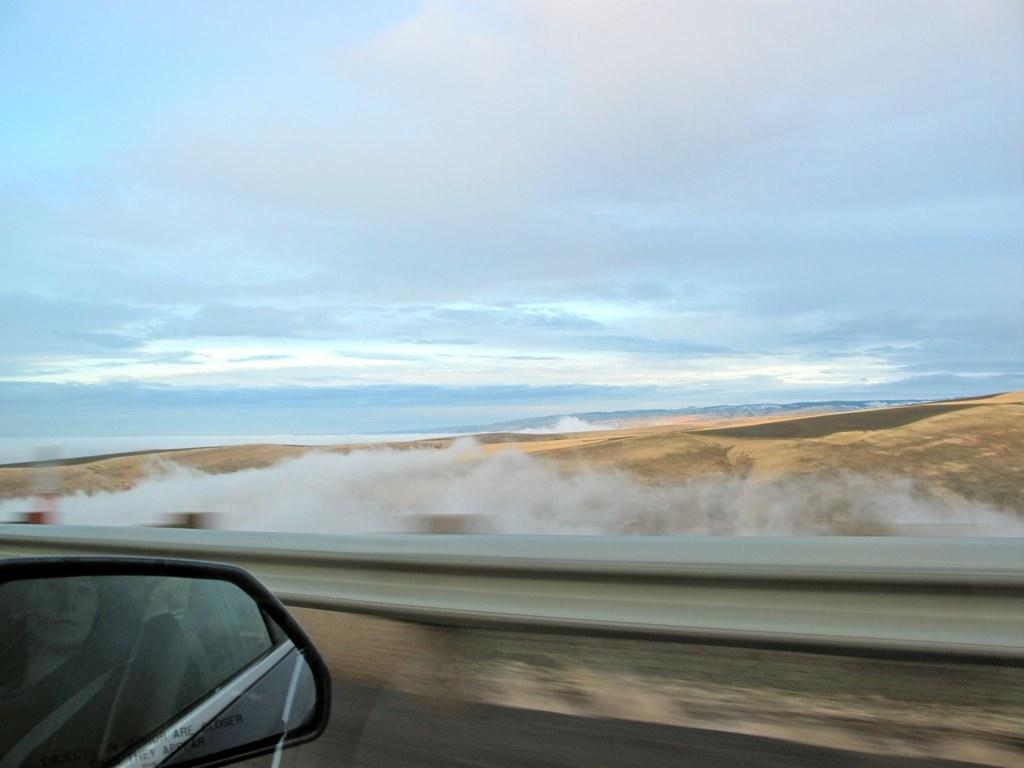Can you describe this image briefly? In this image there is the sky, there is smoke on the ground, there is a fencing truncated, there is road truncated towards the bottom of the image, there is a mirror truncated towards the bottom of the image, there is a person visible in the mirror. 